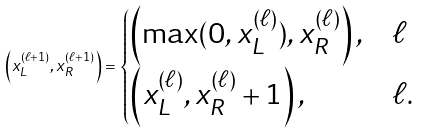Convert formula to latex. <formula><loc_0><loc_0><loc_500><loc_500>\left ( x _ { L } ^ { ( \ell + 1 ) } , x _ { R } ^ { ( \ell + 1 ) } \right ) = \begin{cases} \left ( \max ( 0 , x _ { L } ^ { ( \ell ) } ) , x _ { R } ^ { ( \ell ) } \right ) , & \ell \\ \left ( x _ { L } ^ { ( \ell ) } , x _ { R } ^ { ( \ell ) } + 1 \right ) , & \ell . \end{cases}</formula> 